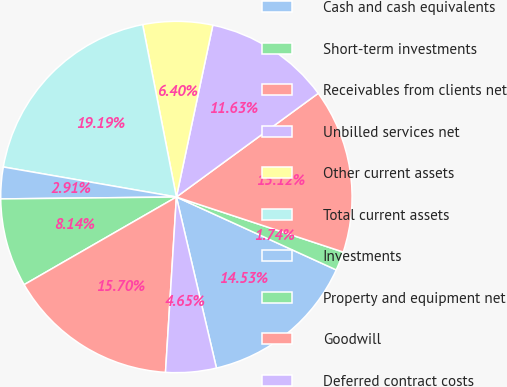Convert chart to OTSL. <chart><loc_0><loc_0><loc_500><loc_500><pie_chart><fcel>Cash and cash equivalents<fcel>Short-term investments<fcel>Receivables from clients net<fcel>Unbilled services net<fcel>Other current assets<fcel>Total current assets<fcel>Investments<fcel>Property and equipment net<fcel>Goodwill<fcel>Deferred contract costs<nl><fcel>14.53%<fcel>1.74%<fcel>15.12%<fcel>11.63%<fcel>6.4%<fcel>19.19%<fcel>2.91%<fcel>8.14%<fcel>15.7%<fcel>4.65%<nl></chart> 